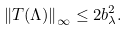Convert formula to latex. <formula><loc_0><loc_0><loc_500><loc_500>\left \| T ( \Lambda ) \right \| _ { \infty } \leq 2 b _ { \lambda } ^ { 2 } .</formula> 